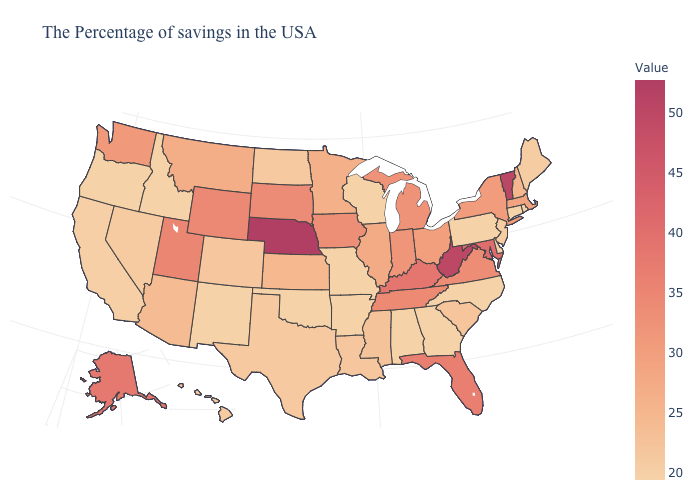Which states have the lowest value in the USA?
Concise answer only. Rhode Island, Connecticut, Delaware, Pennsylvania, North Carolina, Georgia, Alabama, Wisconsin, Missouri, Arkansas, Oklahoma, New Mexico, Idaho, Oregon. Does Illinois have the lowest value in the USA?
Concise answer only. No. Among the states that border New York , does Vermont have the lowest value?
Quick response, please. No. Which states have the highest value in the USA?
Give a very brief answer. Nebraska. Does Iowa have a higher value than Nebraska?
Concise answer only. No. Does Massachusetts have a higher value than North Carolina?
Give a very brief answer. Yes. Among the states that border South Dakota , does North Dakota have the lowest value?
Quick response, please. Yes. Does Hawaii have the lowest value in the USA?
Be succinct. No. 